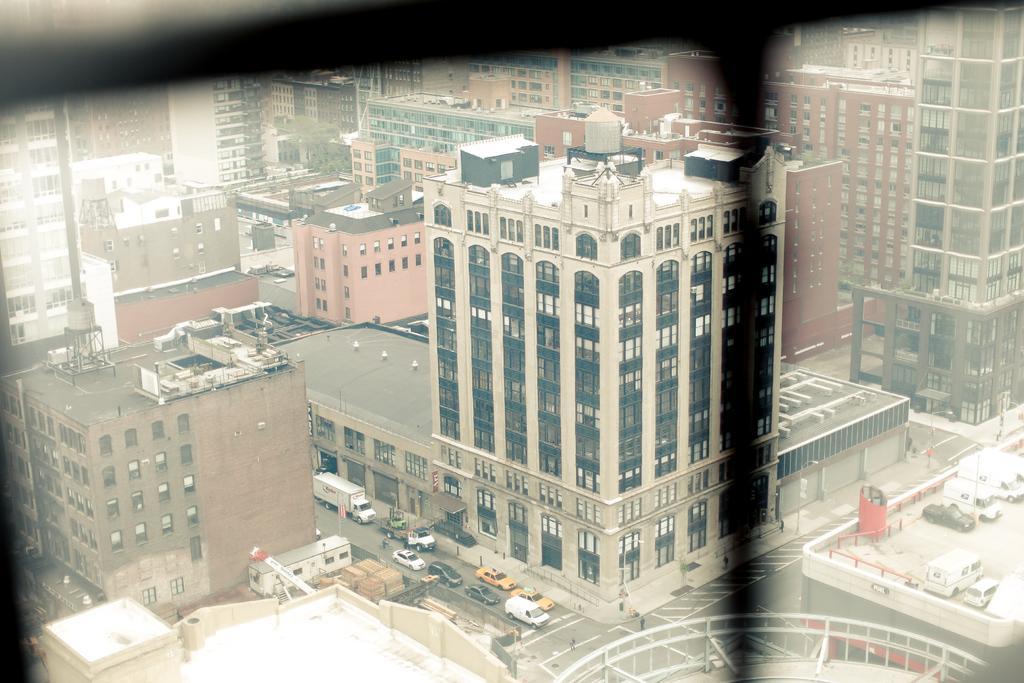How would you summarize this image in a sentence or two? There are vehicles on the road. Here we can see buildings. 